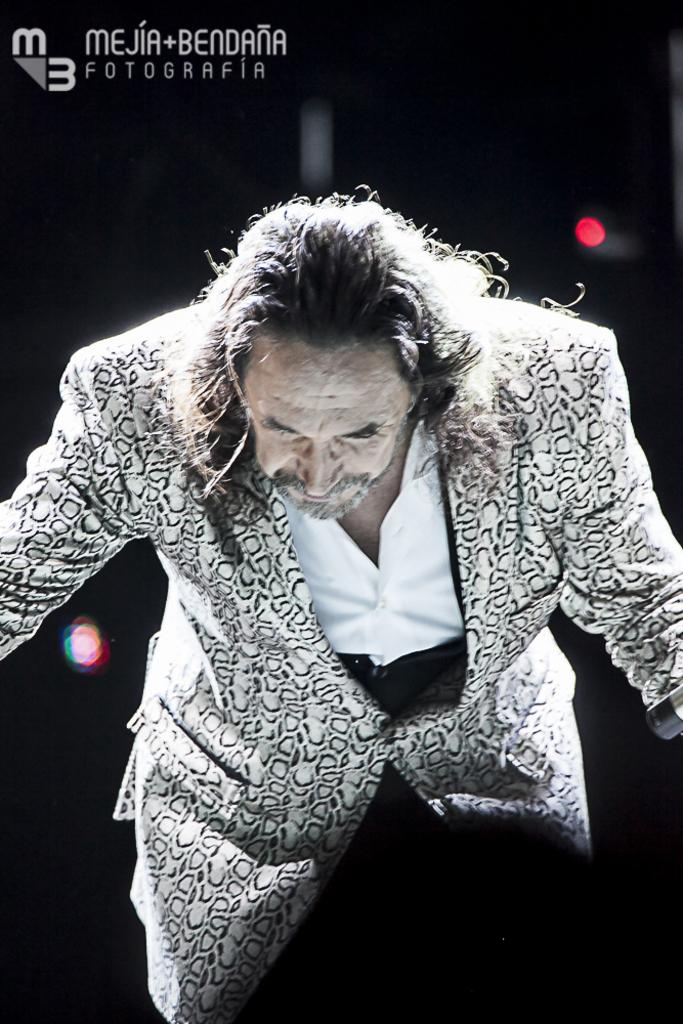What is the main subject of the image? There is a person in the image. What can be seen at the top left of the image? There is text at the top left of the image. How would you describe the overall color scheme of the image? The background of the image is dark. Can you tell me how many snails are crawling on the person's shoulder in the image? There are no snails present in the image; the main subject is a person. What direction is the person looking in the image? The image does not provide information about the person's gaze or direction they are looking. 